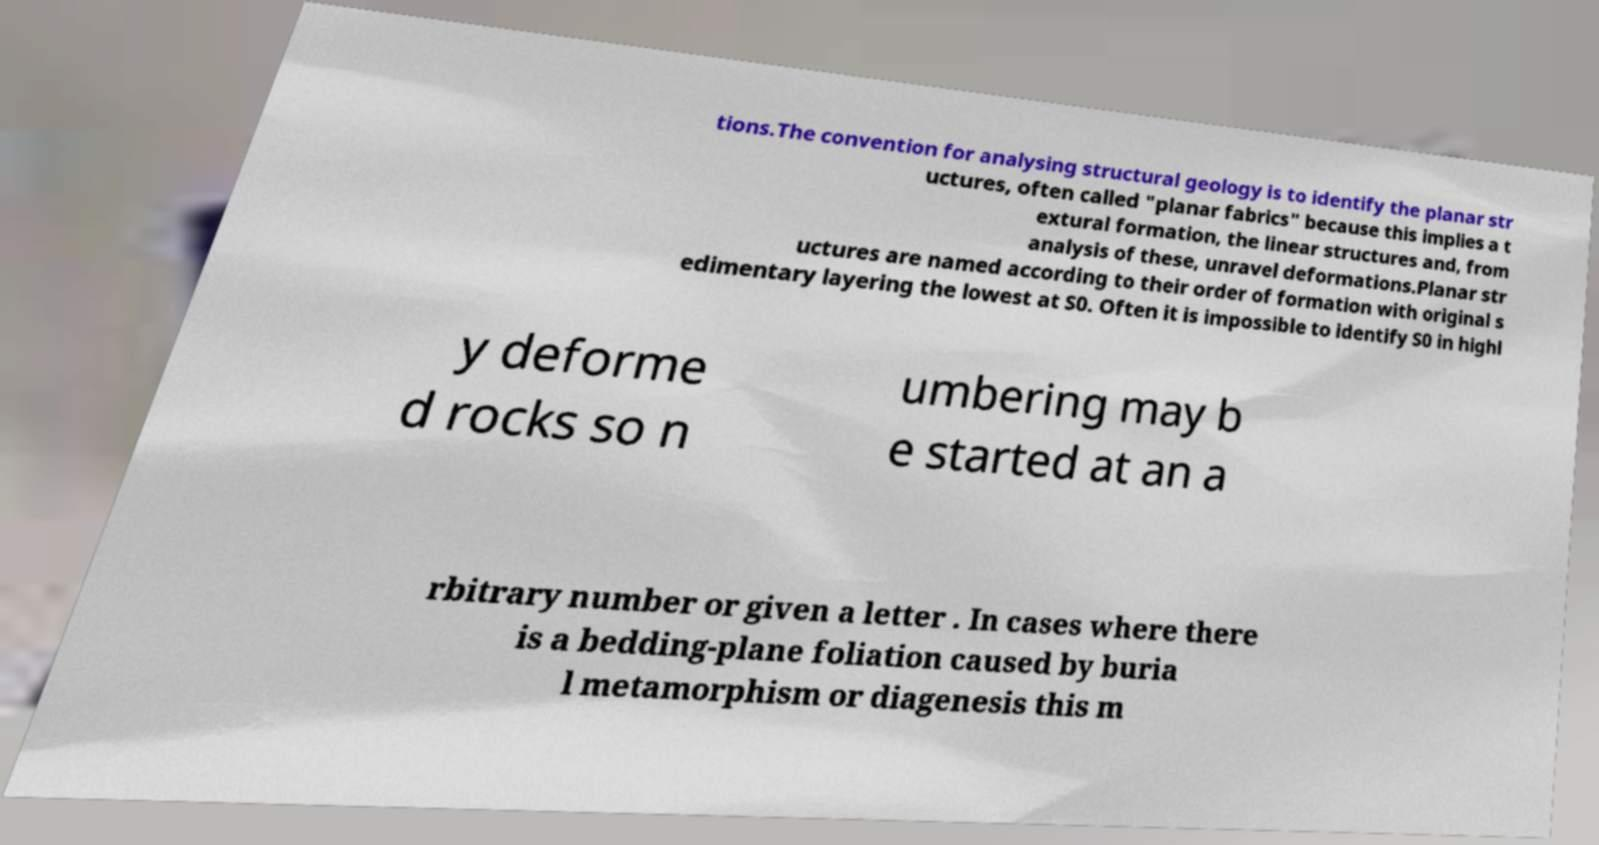Can you accurately transcribe the text from the provided image for me? tions.The convention for analysing structural geology is to identify the planar str uctures, often called "planar fabrics" because this implies a t extural formation, the linear structures and, from analysis of these, unravel deformations.Planar str uctures are named according to their order of formation with original s edimentary layering the lowest at S0. Often it is impossible to identify S0 in highl y deforme d rocks so n umbering may b e started at an a rbitrary number or given a letter . In cases where there is a bedding-plane foliation caused by buria l metamorphism or diagenesis this m 